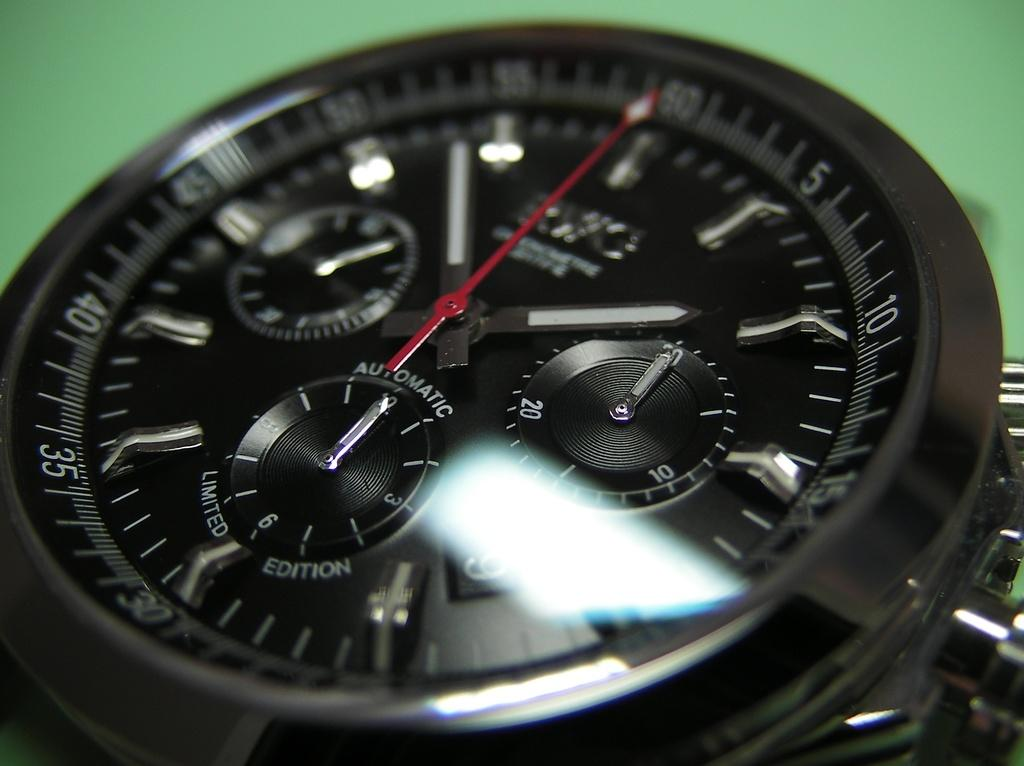<image>
Provide a brief description of the given image. An Automatic Limited Edition of a watch with a black face. 